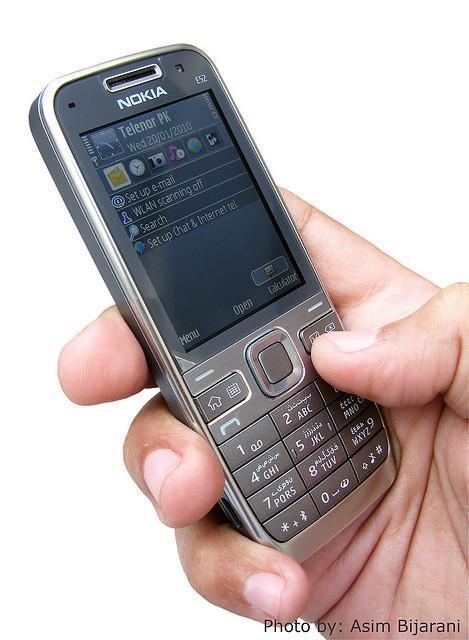How many elephants are pictured?
Give a very brief answer. 0. 